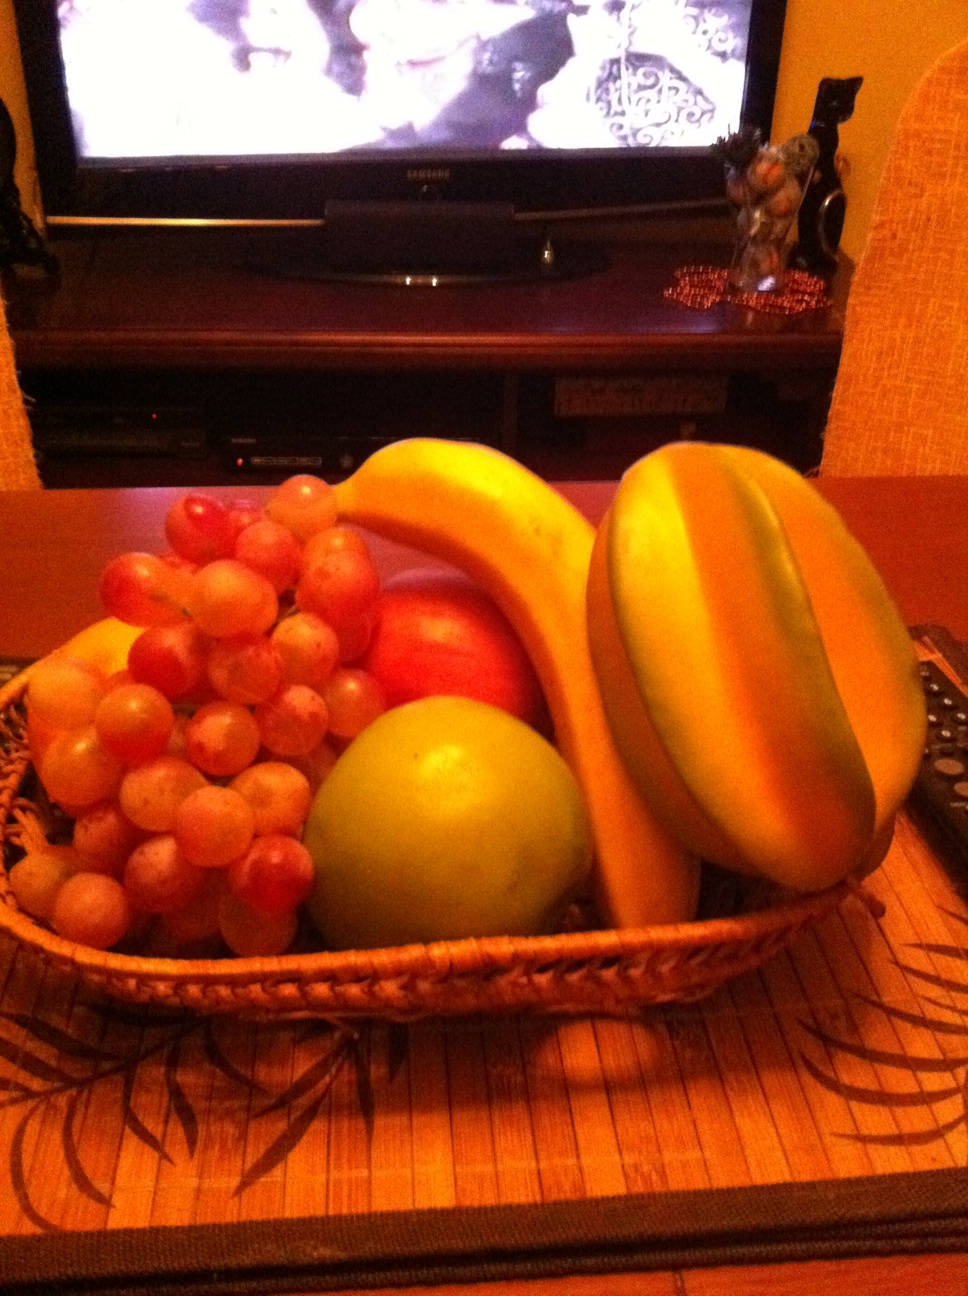Can you tell me what sort of occasion this fruit basket might be prepared for? This type of fruit basket is often assembled for casual enjoyment at home, possibly for snacking during a family gathering or simply as a healthy option readily available on the table.  Are there any fruits in the basket that are particularly health beneficial? Certainly, the bananas are known for their potassium content, which is great for heart health and maintaining proper muscle function. The grapes are rich in antioxidants, and the apple, famously, is associated with various health benefits, including dietary fiber and vitamin C. 